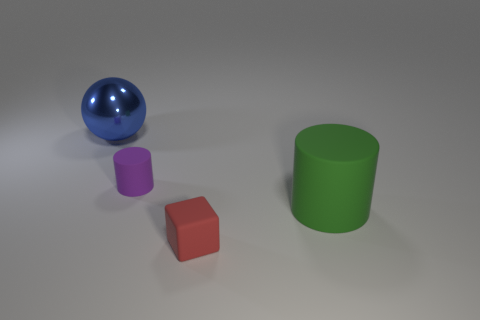Are there any other things that have the same material as the big blue thing?
Ensure brevity in your answer.  No. Does the small matte cylinder have the same color as the large metallic thing?
Your answer should be very brief. No. How many other things are the same shape as the blue object?
Keep it short and to the point. 0. What number of yellow things are either small rubber objects or small cubes?
Provide a succinct answer. 0. The tiny cylinder that is made of the same material as the green thing is what color?
Offer a terse response. Purple. Do the large object that is on the left side of the red matte cube and the large object that is in front of the ball have the same material?
Offer a very short reply. No. There is a big object that is right of the sphere; what is its material?
Your answer should be compact. Rubber. There is a rubber object that is behind the big cylinder; does it have the same shape as the big matte object in front of the tiny purple cylinder?
Ensure brevity in your answer.  Yes. Are there any red matte objects?
Offer a terse response. Yes. There is a green object that is the same shape as the purple matte object; what is its material?
Your response must be concise. Rubber. 